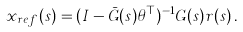<formula> <loc_0><loc_0><loc_500><loc_500>x _ { r e f } ( s ) = ( I - \bar { G } ( s ) \theta ^ { \top } ) ^ { - 1 } G ( s ) r ( s ) \, .</formula> 